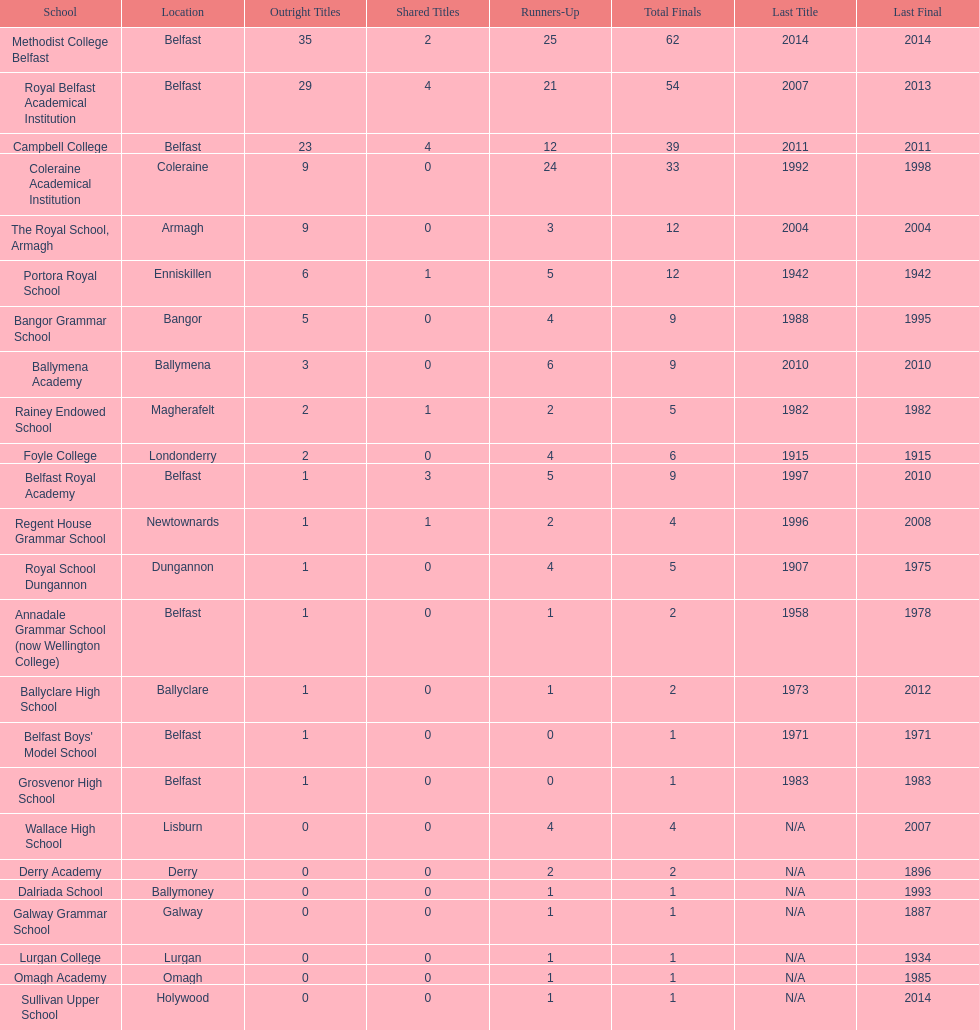Which schools have the largest number of shared titles? Royal Belfast Academical Institution, Campbell College. 